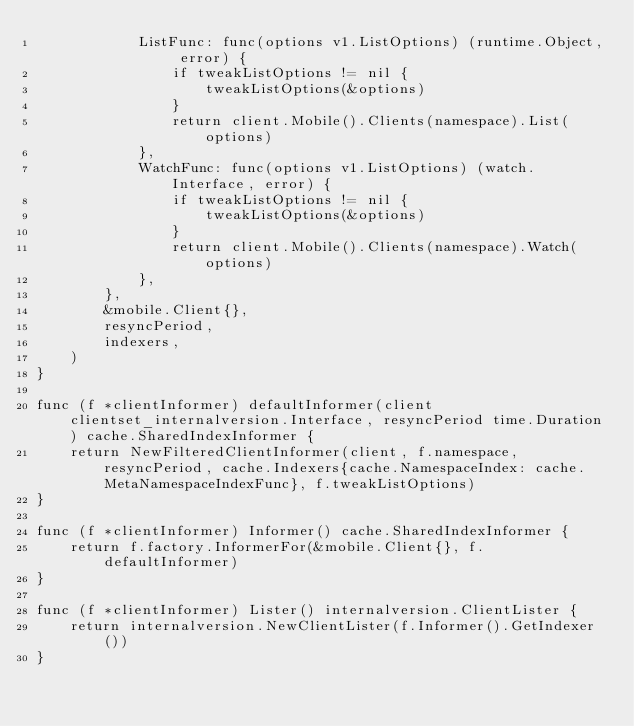<code> <loc_0><loc_0><loc_500><loc_500><_Go_>			ListFunc: func(options v1.ListOptions) (runtime.Object, error) {
				if tweakListOptions != nil {
					tweakListOptions(&options)
				}
				return client.Mobile().Clients(namespace).List(options)
			},
			WatchFunc: func(options v1.ListOptions) (watch.Interface, error) {
				if tweakListOptions != nil {
					tweakListOptions(&options)
				}
				return client.Mobile().Clients(namespace).Watch(options)
			},
		},
		&mobile.Client{},
		resyncPeriod,
		indexers,
	)
}

func (f *clientInformer) defaultInformer(client clientset_internalversion.Interface, resyncPeriod time.Duration) cache.SharedIndexInformer {
	return NewFilteredClientInformer(client, f.namespace, resyncPeriod, cache.Indexers{cache.NamespaceIndex: cache.MetaNamespaceIndexFunc}, f.tweakListOptions)
}

func (f *clientInformer) Informer() cache.SharedIndexInformer {
	return f.factory.InformerFor(&mobile.Client{}, f.defaultInformer)
}

func (f *clientInformer) Lister() internalversion.ClientLister {
	return internalversion.NewClientLister(f.Informer().GetIndexer())
}
</code> 